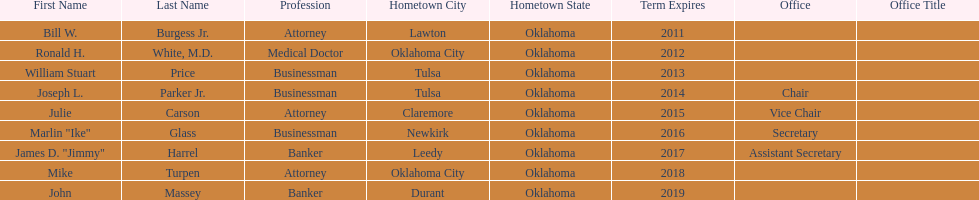Other than william stuart price, which other businessman was born in tulsa? Joseph L. Parker Jr. 